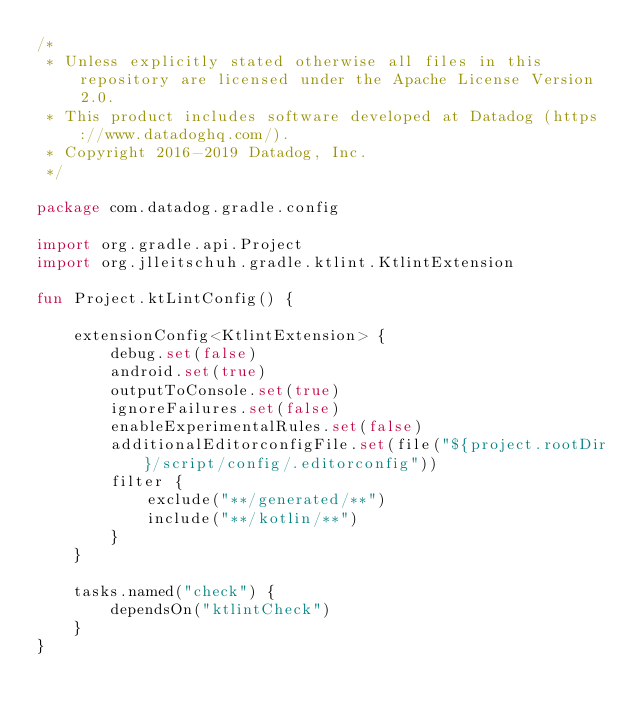<code> <loc_0><loc_0><loc_500><loc_500><_Kotlin_>/*
 * Unless explicitly stated otherwise all files in this repository are licensed under the Apache License Version 2.0.
 * This product includes software developed at Datadog (https://www.datadoghq.com/).
 * Copyright 2016-2019 Datadog, Inc.
 */

package com.datadog.gradle.config

import org.gradle.api.Project
import org.jlleitschuh.gradle.ktlint.KtlintExtension

fun Project.ktLintConfig() {

    extensionConfig<KtlintExtension> {
        debug.set(false)
        android.set(true)
        outputToConsole.set(true)
        ignoreFailures.set(false)
        enableExperimentalRules.set(false)
        additionalEditorconfigFile.set(file("${project.rootDir}/script/config/.editorconfig"))
        filter {
            exclude("**/generated/**")
            include("**/kotlin/**")
        }
    }

    tasks.named("check") {
        dependsOn("ktlintCheck")
    }
}
</code> 